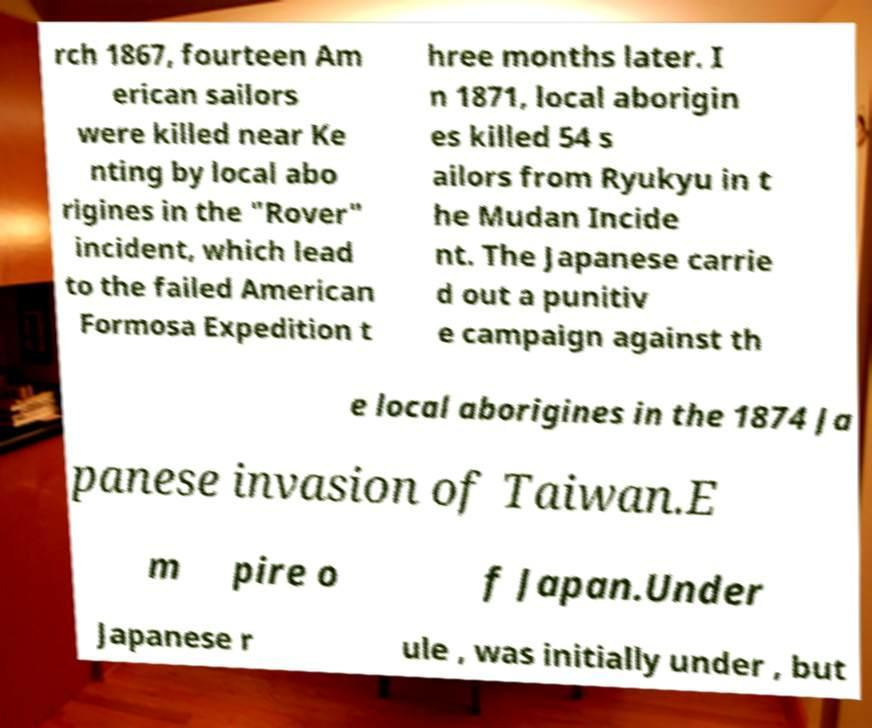Please read and relay the text visible in this image. What does it say? rch 1867, fourteen Am erican sailors were killed near Ke nting by local abo rigines in the "Rover" incident, which lead to the failed American Formosa Expedition t hree months later. I n 1871, local aborigin es killed 54 s ailors from Ryukyu in t he Mudan Incide nt. The Japanese carrie d out a punitiv e campaign against th e local aborigines in the 1874 Ja panese invasion of Taiwan.E m pire o f Japan.Under Japanese r ule , was initially under , but 